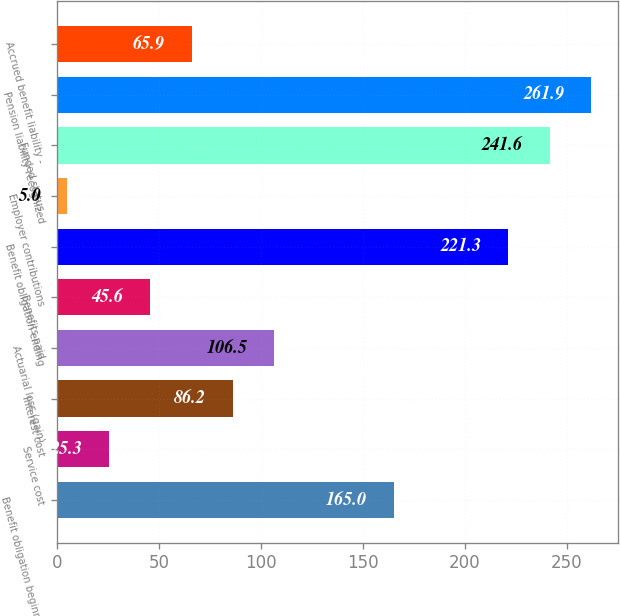Convert chart to OTSL. <chart><loc_0><loc_0><loc_500><loc_500><bar_chart><fcel>Benefit obligation beginning<fcel>Service cost<fcel>Interest cost<fcel>Actuarial loss (gain)<fcel>Benefits paid<fcel>Benefit obligation ending<fcel>Employer contributions<fcel>Funded status<fcel>Pension liability recognized<fcel>Accrued benefit liability -<nl><fcel>165<fcel>25.3<fcel>86.2<fcel>106.5<fcel>45.6<fcel>221.3<fcel>5<fcel>241.6<fcel>261.9<fcel>65.9<nl></chart> 